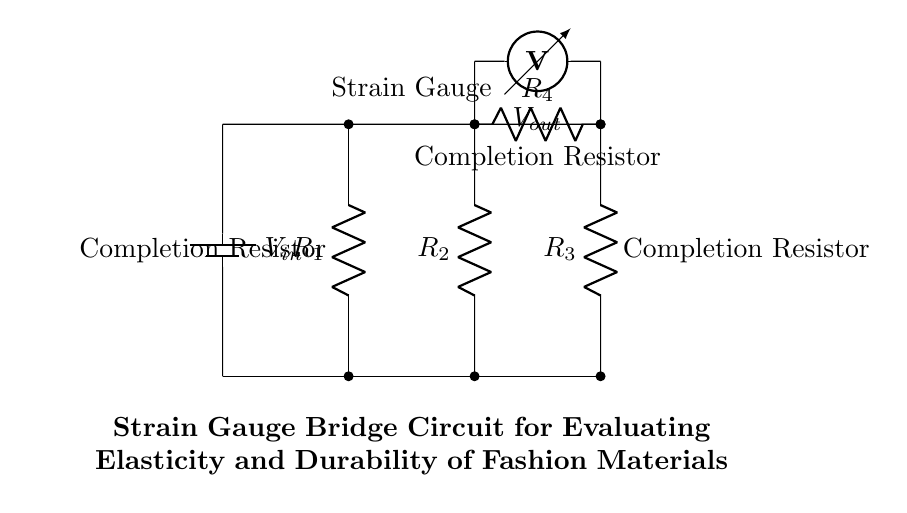What type of circuit is shown? The circuit is a bridge circuit, specifically a strain gauge bridge circuit used for measuring resistance changes in the strain gauge to evaluate elasticity and durability of materials.
Answer: bridge circuit How many resistors are in the circuit? There are four resistors labeled R1, R2, R3, and R4 connected in the bridge configuration.
Answer: four resistors What is the role of the strain gauge in this circuit? The strain gauge measures the deformation of materials by changing its resistance in response to applied strain; this change affects the output voltage Vout of the bridge circuit.
Answer: measures strain What is the purpose of the voltmeter? The voltmeter measures the output voltage Vout, which indicates the difference in voltage between the two branches of the bridge, affected by the resistance of the strain gauge.
Answer: measure output voltage How many voltage sources are present in the circuit? There is one voltage source labeled V_in that provides the input voltage to the bridge circuit.
Answer: one voltage source What does resistance change in a strain gauge indicate? A change in resistance indicates a variation in strain or deformation of the material being tested, which reflects its elasticity and durability.
Answer: strain variation What happens if one resistor fails in the bridge? If one resistor fails, the balance of the bridge is disrupted, leading to an inaccurate measurement of the output voltage Vout, thus compromising the assessment of the material's properties.
Answer: inaccurate measurement 